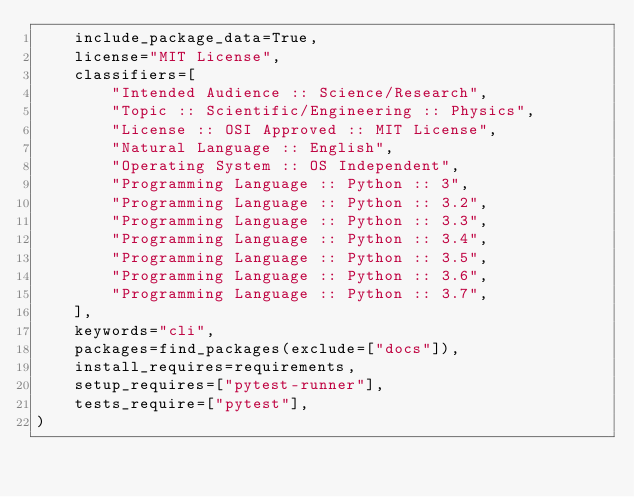Convert code to text. <code><loc_0><loc_0><loc_500><loc_500><_Python_>    include_package_data=True,
    license="MIT License",
    classifiers=[
        "Intended Audience :: Science/Research",
        "Topic :: Scientific/Engineering :: Physics",
        "License :: OSI Approved :: MIT License",
        "Natural Language :: English",
        "Operating System :: OS Independent",
        "Programming Language :: Python :: 3",
        "Programming Language :: Python :: 3.2",
        "Programming Language :: Python :: 3.3",
        "Programming Language :: Python :: 3.4",
        "Programming Language :: Python :: 3.5",
        "Programming Language :: Python :: 3.6",
        "Programming Language :: Python :: 3.7",
    ],
    keywords="cli",
    packages=find_packages(exclude=["docs"]),
    install_requires=requirements,
    setup_requires=["pytest-runner"],
    tests_require=["pytest"],
)
</code> 